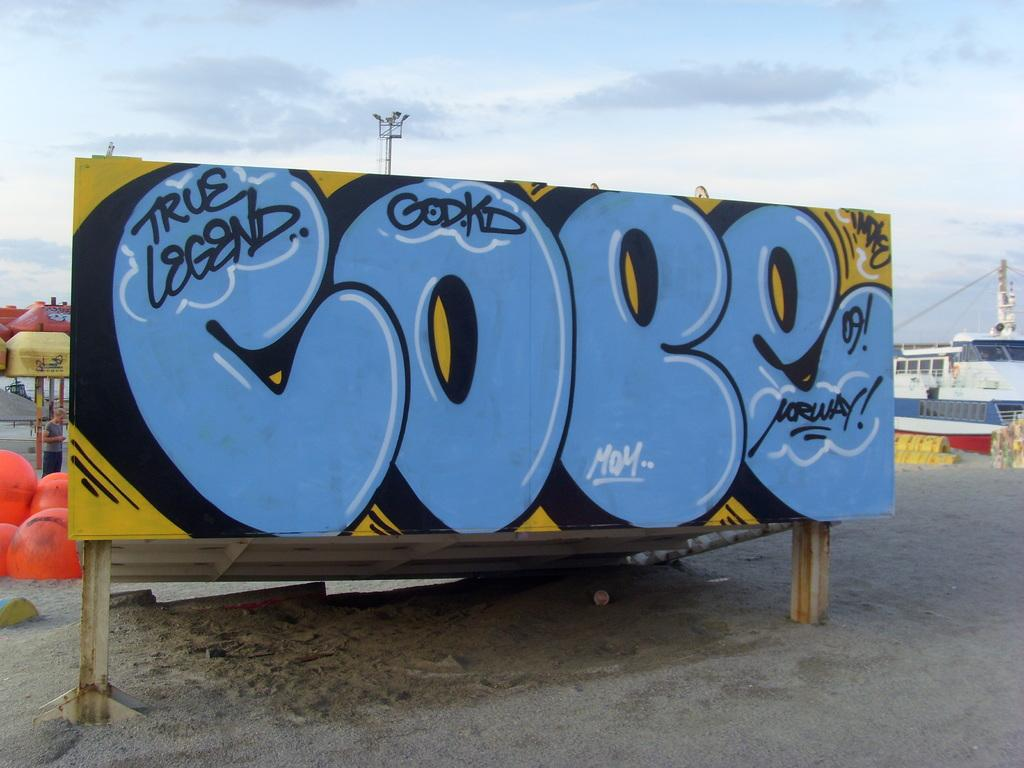<image>
Describe the image concisely. A large billboard says True Legend in graffiti letters on a beach. 